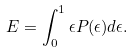Convert formula to latex. <formula><loc_0><loc_0><loc_500><loc_500>E = \int _ { 0 } ^ { 1 } \epsilon P ( \epsilon ) d \epsilon .</formula> 